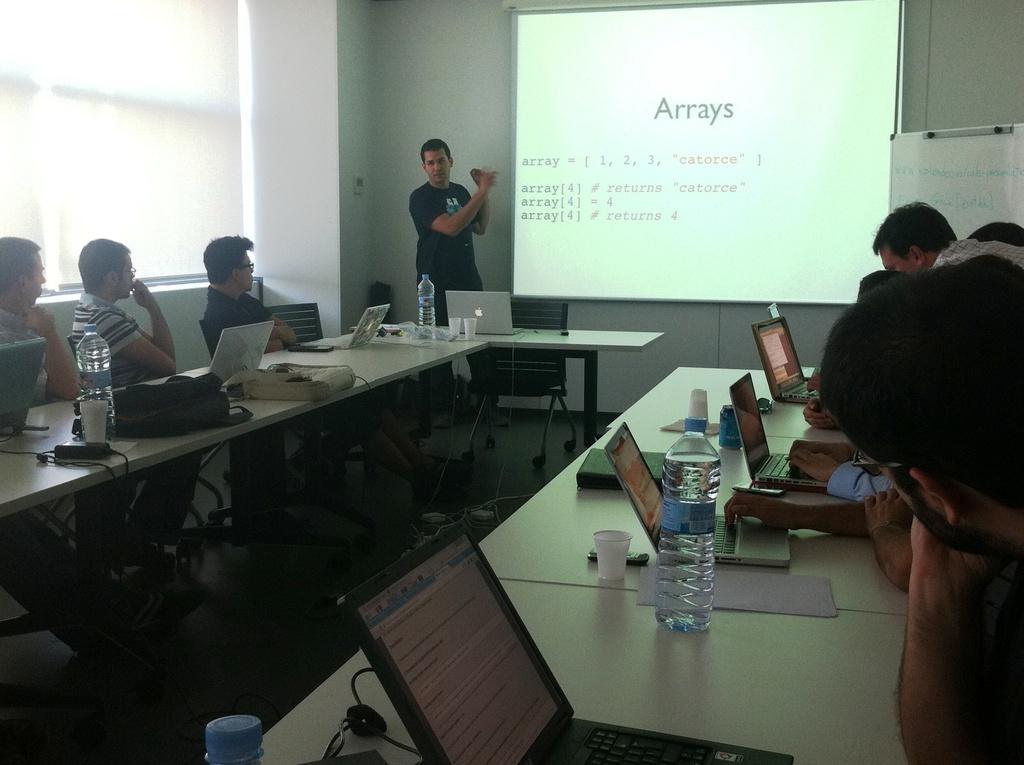What is the last word in red?
Your answer should be very brief. Catorce. What is the title of the slide being shown?
Provide a short and direct response. Arrays. 